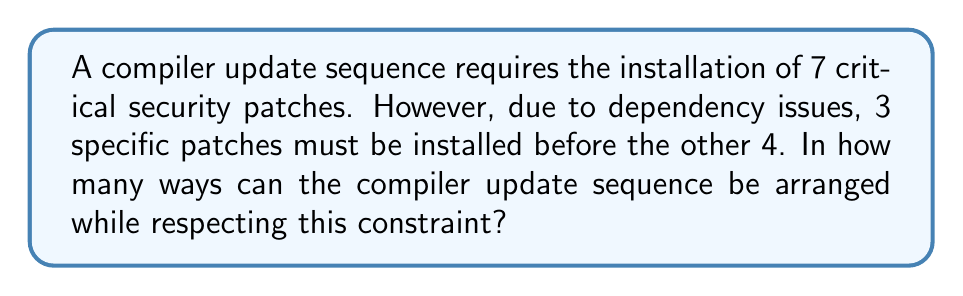Could you help me with this problem? Let's approach this problem step-by-step:

1) First, we need to consider the constraint: 3 specific patches must be installed before the other 4.

2) This problem can be broken down into two parts:
   a) Arranging the 3 specific patches among themselves
   b) Arranging the 4 remaining patches among themselves

3) For the 3 specific patches:
   - These can be arranged in $3!$ ways

4) For the 4 remaining patches:
   - These can be arranged in $4!$ ways

5) Now, we need to consider how these two groups can be arranged relative to each other. We can think of this as having 4 "slots" where we can insert the group of 3 patches:

   _ 4 _ 3 _ 2 _ 1 _

   Where the numbers represent the 4 remaining patches, and the underscores represent potential positions for the group of 3 patches.

6) This gives us 5 possible positions for the group of 3 patches (including before the first patch and after the last patch).

7) By the multiplication principle, the total number of ways to arrange the patches is:

   $$ 3! \times 4! \times 5 $$

8) Calculating this:
   $$ (3 \times 2 \times 1) \times (4 \times 3 \times 2 \times 1) \times 5 $$
   $$ = 6 \times 24 \times 5 $$
   $$ = 720 $$

Therefore, there are 720 ways to arrange the security patches in the compiler update sequence while respecting the given constraint.
Answer: 720 